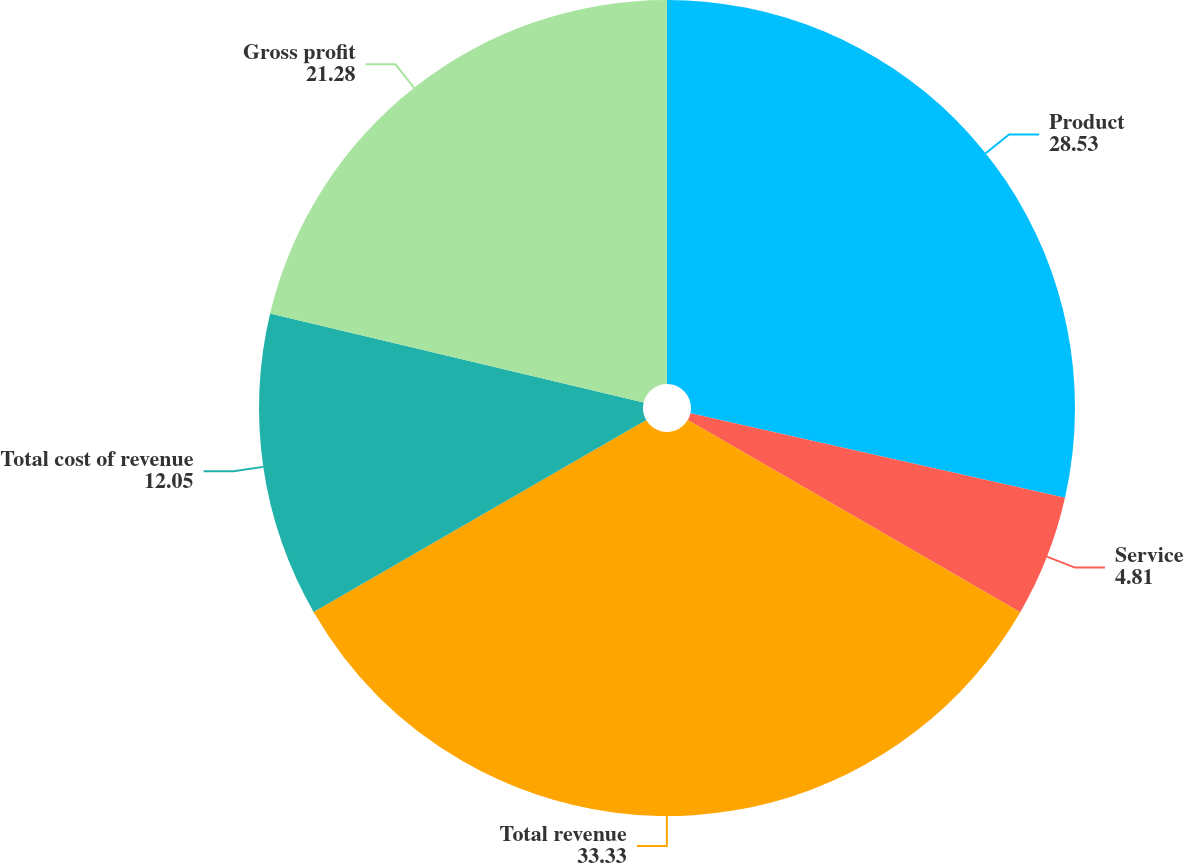Convert chart to OTSL. <chart><loc_0><loc_0><loc_500><loc_500><pie_chart><fcel>Product<fcel>Service<fcel>Total revenue<fcel>Total cost of revenue<fcel>Gross profit<nl><fcel>28.53%<fcel>4.81%<fcel>33.33%<fcel>12.05%<fcel>21.28%<nl></chart> 